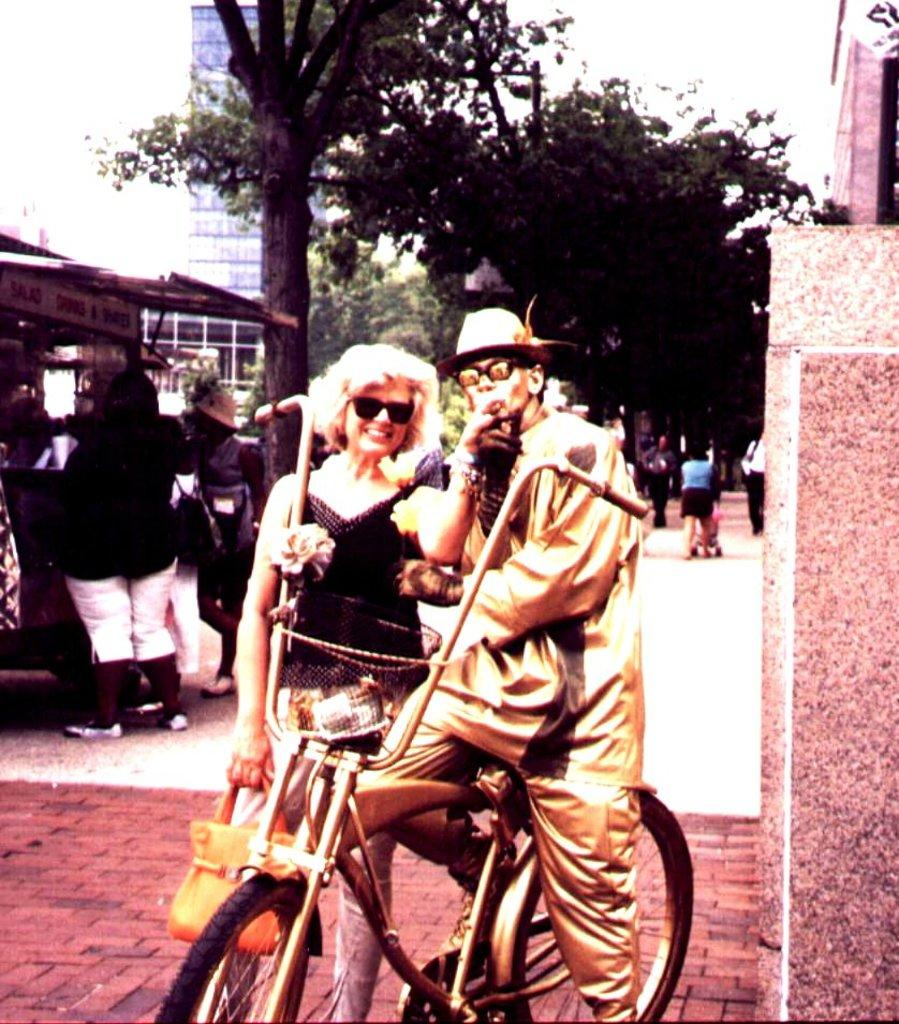What is the man doing in the image? The man is standing on a cycle. Who is with the man in the image? There is a woman standing beside the man. What can be seen behind the man and woman? There are trees behind the man and woman. What is visible in the distance in the image? There are buildings visible in the background. What type of sponge is the man using to clean the cycle in the image? There is no sponge present in the image, and the man is not cleaning the cycle. 